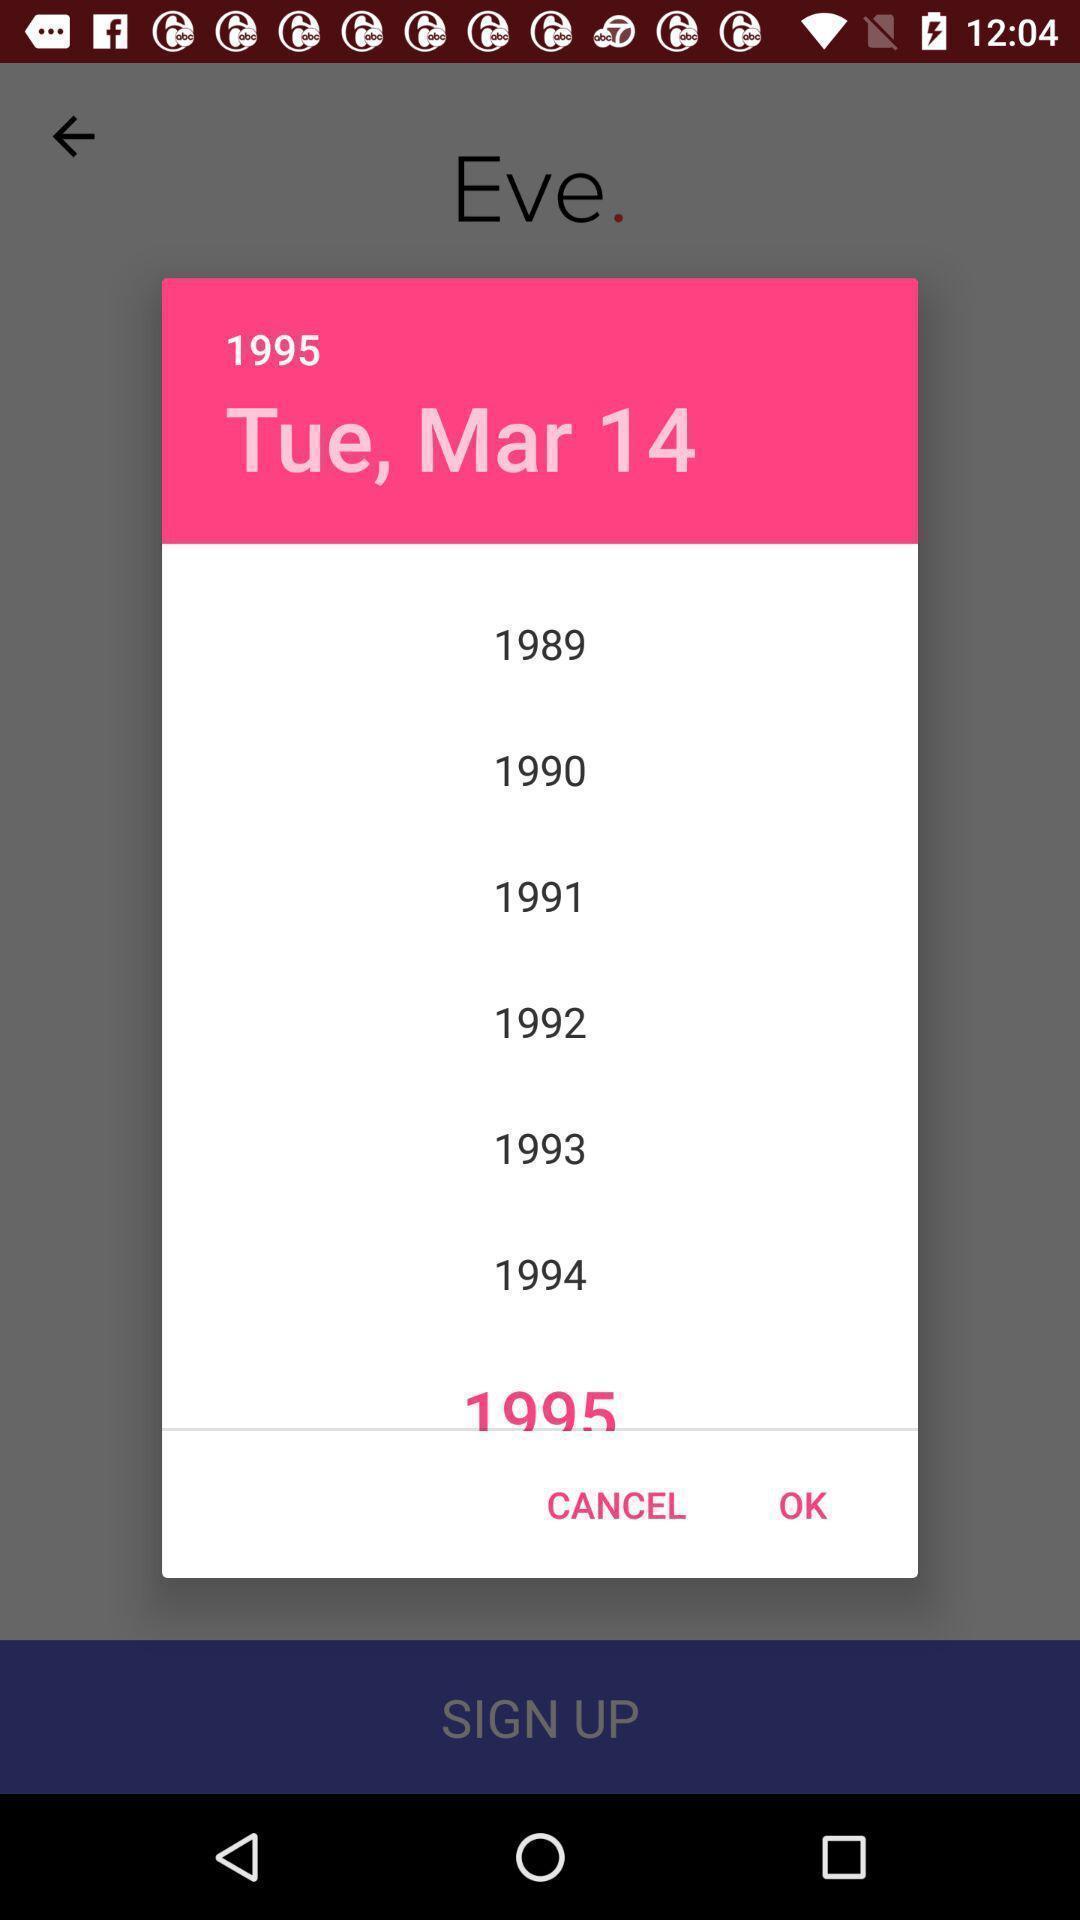Summarize the main components in this picture. Pop- up to select the year. 